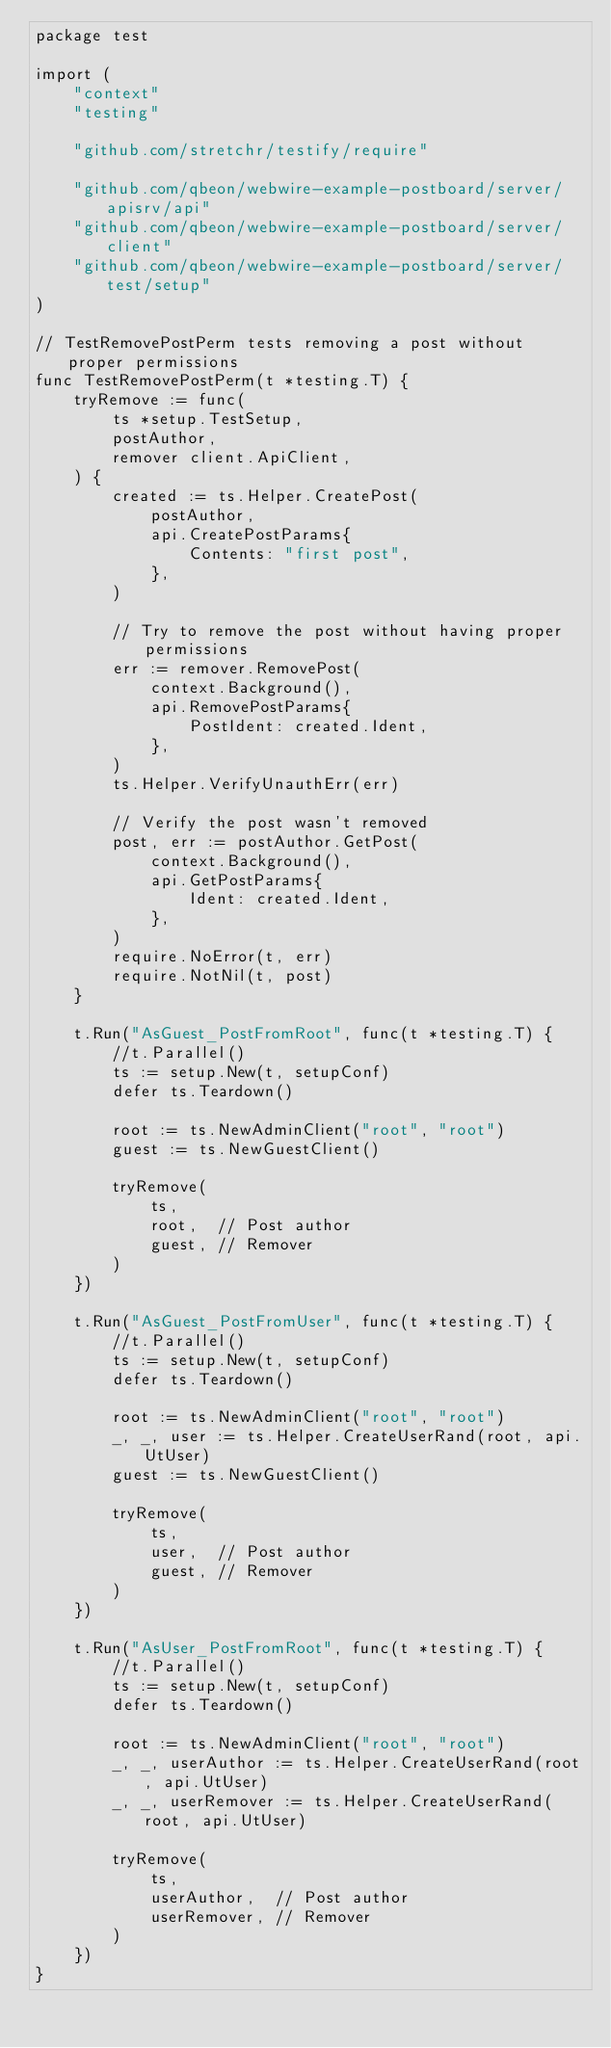Convert code to text. <code><loc_0><loc_0><loc_500><loc_500><_Go_>package test

import (
	"context"
	"testing"

	"github.com/stretchr/testify/require"

	"github.com/qbeon/webwire-example-postboard/server/apisrv/api"
	"github.com/qbeon/webwire-example-postboard/server/client"
	"github.com/qbeon/webwire-example-postboard/server/test/setup"
)

// TestRemovePostPerm tests removing a post without proper permissions
func TestRemovePostPerm(t *testing.T) {
	tryRemove := func(
		ts *setup.TestSetup,
		postAuthor,
		remover client.ApiClient,
	) {
		created := ts.Helper.CreatePost(
			postAuthor,
			api.CreatePostParams{
				Contents: "first post",
			},
		)

		// Try to remove the post without having proper permissions
		err := remover.RemovePost(
			context.Background(),
			api.RemovePostParams{
				PostIdent: created.Ident,
			},
		)
		ts.Helper.VerifyUnauthErr(err)

		// Verify the post wasn't removed
		post, err := postAuthor.GetPost(
			context.Background(),
			api.GetPostParams{
				Ident: created.Ident,
			},
		)
		require.NoError(t, err)
		require.NotNil(t, post)
	}

	t.Run("AsGuest_PostFromRoot", func(t *testing.T) {
		//t.Parallel()
		ts := setup.New(t, setupConf)
		defer ts.Teardown()

		root := ts.NewAdminClient("root", "root")
		guest := ts.NewGuestClient()

		tryRemove(
			ts,
			root,  // Post author
			guest, // Remover
		)
	})

	t.Run("AsGuest_PostFromUser", func(t *testing.T) {
		//t.Parallel()
		ts := setup.New(t, setupConf)
		defer ts.Teardown()

		root := ts.NewAdminClient("root", "root")
		_, _, user := ts.Helper.CreateUserRand(root, api.UtUser)
		guest := ts.NewGuestClient()

		tryRemove(
			ts,
			user,  // Post author
			guest, // Remover
		)
	})

	t.Run("AsUser_PostFromRoot", func(t *testing.T) {
		//t.Parallel()
		ts := setup.New(t, setupConf)
		defer ts.Teardown()

		root := ts.NewAdminClient("root", "root")
		_, _, userAuthor := ts.Helper.CreateUserRand(root, api.UtUser)
		_, _, userRemover := ts.Helper.CreateUserRand(root, api.UtUser)

		tryRemove(
			ts,
			userAuthor,  // Post author
			userRemover, // Remover
		)
	})
}
</code> 